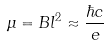<formula> <loc_0><loc_0><loc_500><loc_500>\mu = B l ^ { 2 } \approx \frac { \hbar { c } } { e }</formula> 